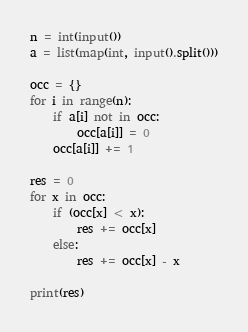<code> <loc_0><loc_0><loc_500><loc_500><_Python_>n = int(input())
a = list(map(int, input().split()))

occ = {}
for i in range(n):
    if a[i] not in occ:
        occ[a[i]] = 0
    occ[a[i]] += 1

res = 0
for x in occ:
    if (occ[x] < x):
        res += occ[x]
    else:
        res += occ[x] - x

print(res)
</code> 